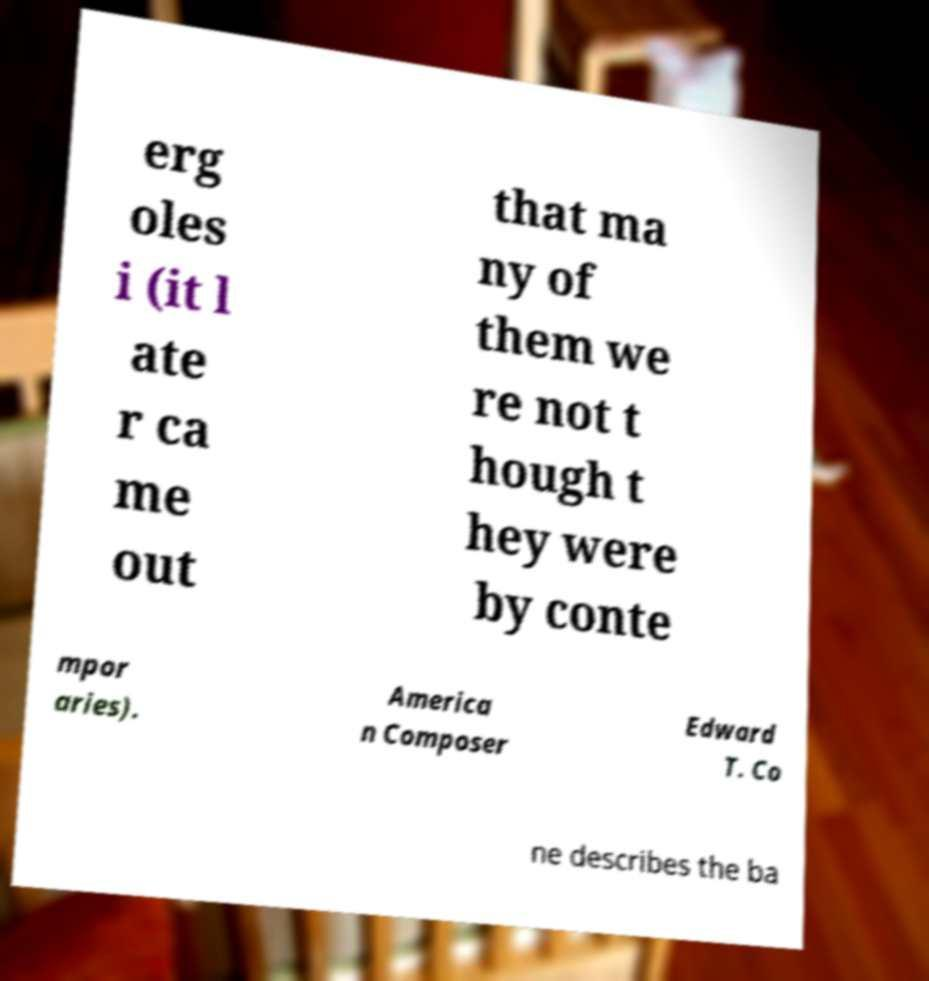What messages or text are displayed in this image? I need them in a readable, typed format. erg oles i (it l ate r ca me out that ma ny of them we re not t hough t hey were by conte mpor aries). America n Composer Edward T. Co ne describes the ba 